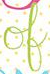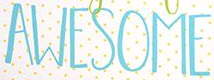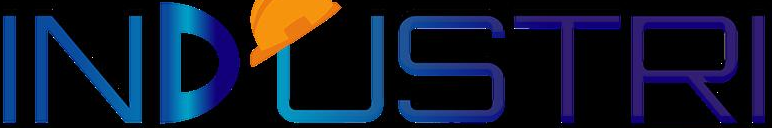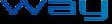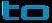Read the text from these images in sequence, separated by a semicolon. of; AWESOME; INDUSTRI; way; to 